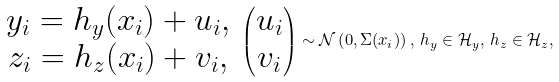Convert formula to latex. <formula><loc_0><loc_0><loc_500><loc_500>\begin{array} { c } y _ { i } = h _ { y } ( x _ { i } ) + u _ { i } , \\ z _ { i } = h _ { z } ( x _ { i } ) + v _ { i } , \end{array} \begin{pmatrix} u _ { i } \\ v _ { i } \end{pmatrix} \sim \mathcal { N } \left ( 0 , \Sigma ( x _ { i } ) \right ) , \, h _ { y } \in \mathcal { H } _ { y } , \, h _ { z } \in \mathcal { H } _ { z } ,</formula> 